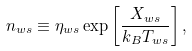<formula> <loc_0><loc_0><loc_500><loc_500>n _ { w s } \equiv \eta _ { w s } \exp \left [ \frac { X _ { w s } } { k _ { B } T _ { w s } } \right ] ,</formula> 